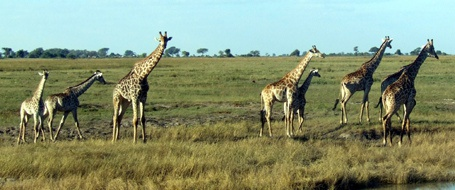Describe the objects in this image and their specific colors. I can see giraffe in lightblue, black, tan, khaki, and olive tones, giraffe in lightblue, black, gray, and tan tones, giraffe in lightblue, tan, khaki, olive, and black tones, giraffe in lightblue, black, gray, darkgreen, and olive tones, and giraffe in lightblue, black, tan, and gray tones in this image. 